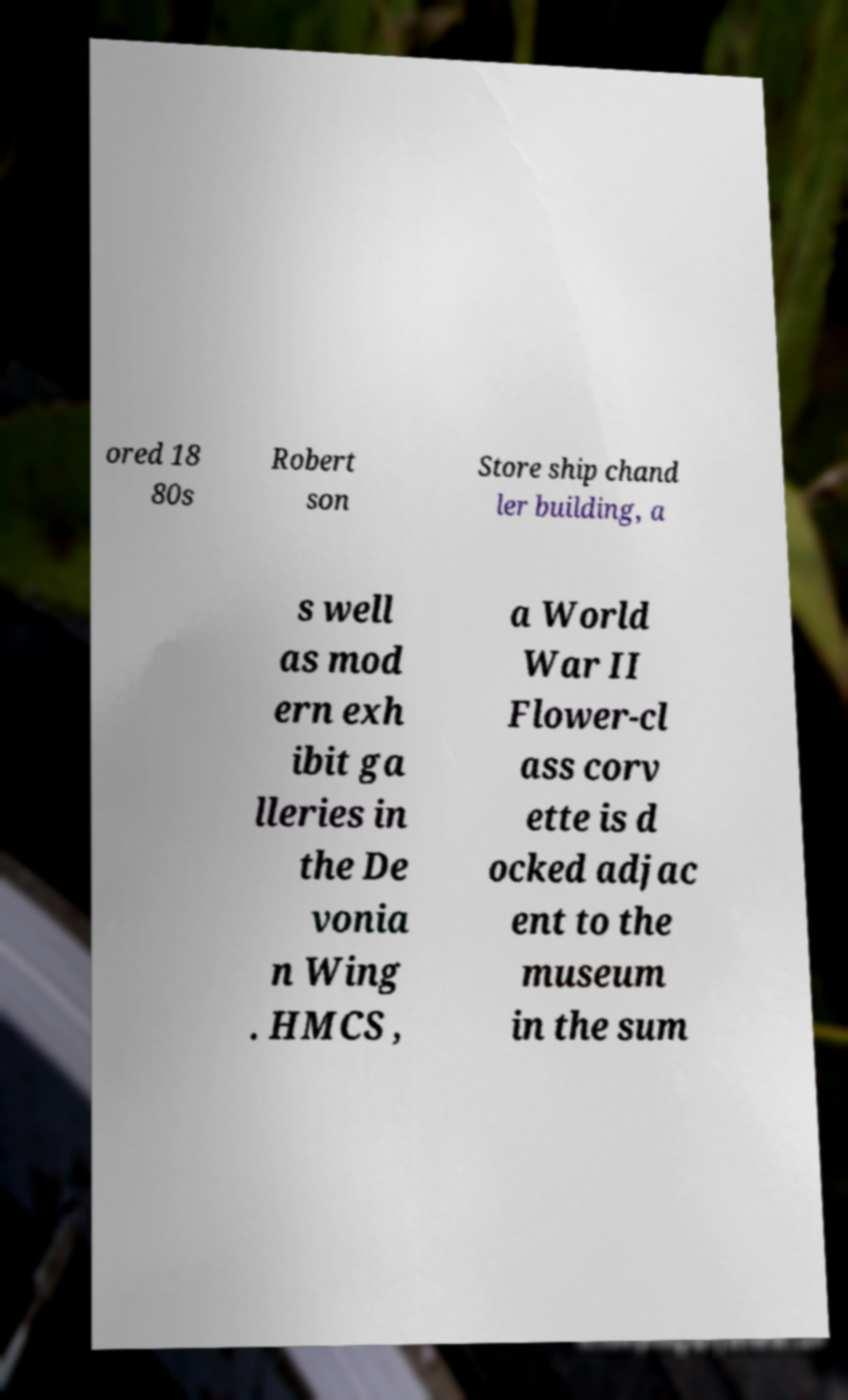Could you extract and type out the text from this image? ored 18 80s Robert son Store ship chand ler building, a s well as mod ern exh ibit ga lleries in the De vonia n Wing . HMCS , a World War II Flower-cl ass corv ette is d ocked adjac ent to the museum in the sum 